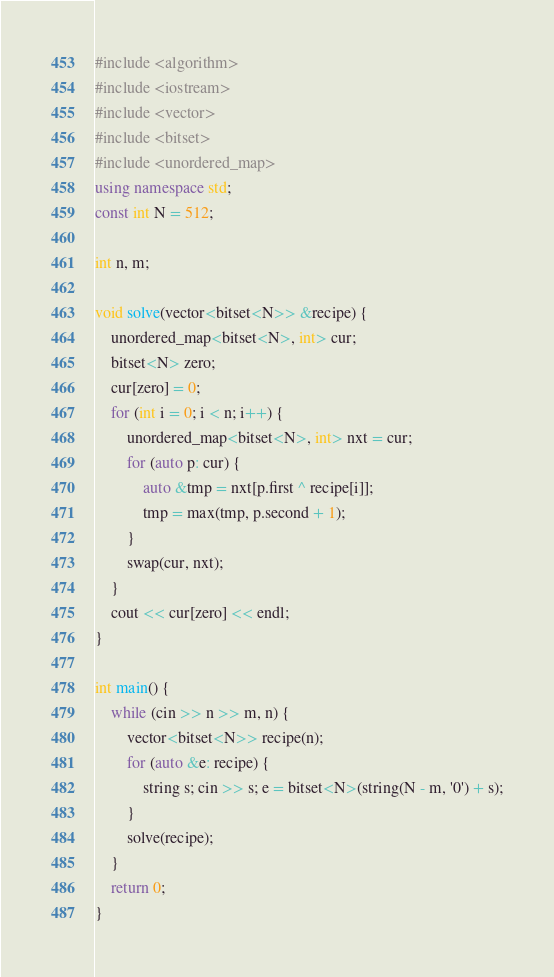Convert code to text. <code><loc_0><loc_0><loc_500><loc_500><_C++_>#include <algorithm>
#include <iostream>
#include <vector>
#include <bitset>
#include <unordered_map>
using namespace std;
const int N = 512;

int n, m;

void solve(vector<bitset<N>> &recipe) {
    unordered_map<bitset<N>, int> cur;
    bitset<N> zero;
    cur[zero] = 0;
    for (int i = 0; i < n; i++) {
        unordered_map<bitset<N>, int> nxt = cur;
        for (auto p: cur) {
            auto &tmp = nxt[p.first ^ recipe[i]];
            tmp = max(tmp, p.second + 1);
        }
        swap(cur, nxt);
    }
    cout << cur[zero] << endl;
}

int main() {
    while (cin >> n >> m, n) {
        vector<bitset<N>> recipe(n);
        for (auto &e: recipe) {
            string s; cin >> s; e = bitset<N>(string(N - m, '0') + s);
        }
        solve(recipe);
    }
    return 0;
}
</code> 